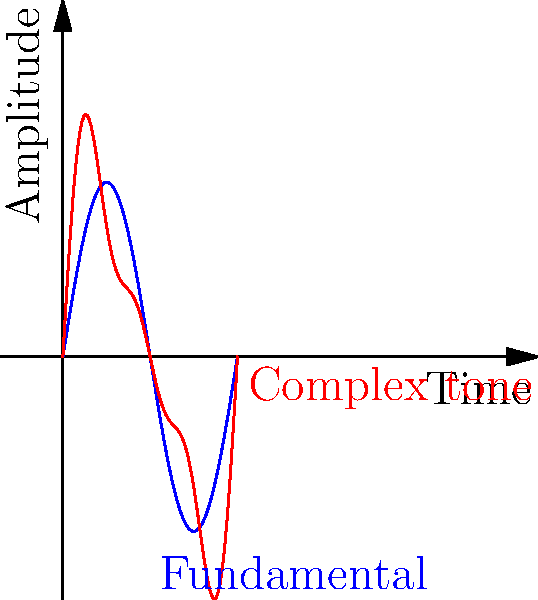In the context of singing voices, the graph shows a fundamental frequency (blue) and a complex tone (red). What physical phenomenon is represented by the difference between these two waveforms, and how does it relate to the richness of a singing voice? To understand this phenomenon, let's break it down step-by-step:

1. The blue curve represents the fundamental frequency, which is the lowest and usually the strongest frequency in a musical note.

2. The red curve represents a complex tone, which is what we actually hear when someone sings.

3. The difference between these two waveforms is caused by the presence of overtones or harmonics.

4. Harmonics are integer multiples of the fundamental frequency. In this case, we can see the effects of the 2nd and 3rd harmonics added to the fundamental.

5. The presence of harmonics creates the complex waveform (red) by adding to and modifying the simple sine wave of the fundamental (blue).

6. In singing, these harmonics contribute to the timbre or tone color of the voice. They're what make different voices sound unique, even when singing the same note.

7. A voice with stronger harmonics will generally sound richer and more complex. This is often associated with trained or mature voices.

8. Different types of singing voices (e.g., bass, tenor, alto, soprano) will produce different patterns of harmonics, contributing to their distinctive sound qualities.

9. The strength and number of harmonics can be influenced by factors such as vocal technique, the shape of the vocal tract, and the specific vowel being sung.

This phenomenon explains why a simple electronic tone generator sounds "thin" compared to a human voice singing the same note - it lacks the rich harmonic structure that our voices naturally produce.
Answer: Harmonics; they add complexity and richness to the voice's timbre. 